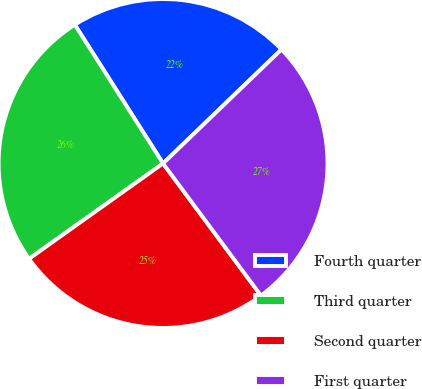Convert chart. <chart><loc_0><loc_0><loc_500><loc_500><pie_chart><fcel>Fourth quarter<fcel>Third quarter<fcel>Second quarter<fcel>First quarter<nl><fcel>21.82%<fcel>25.83%<fcel>25.31%<fcel>27.05%<nl></chart> 